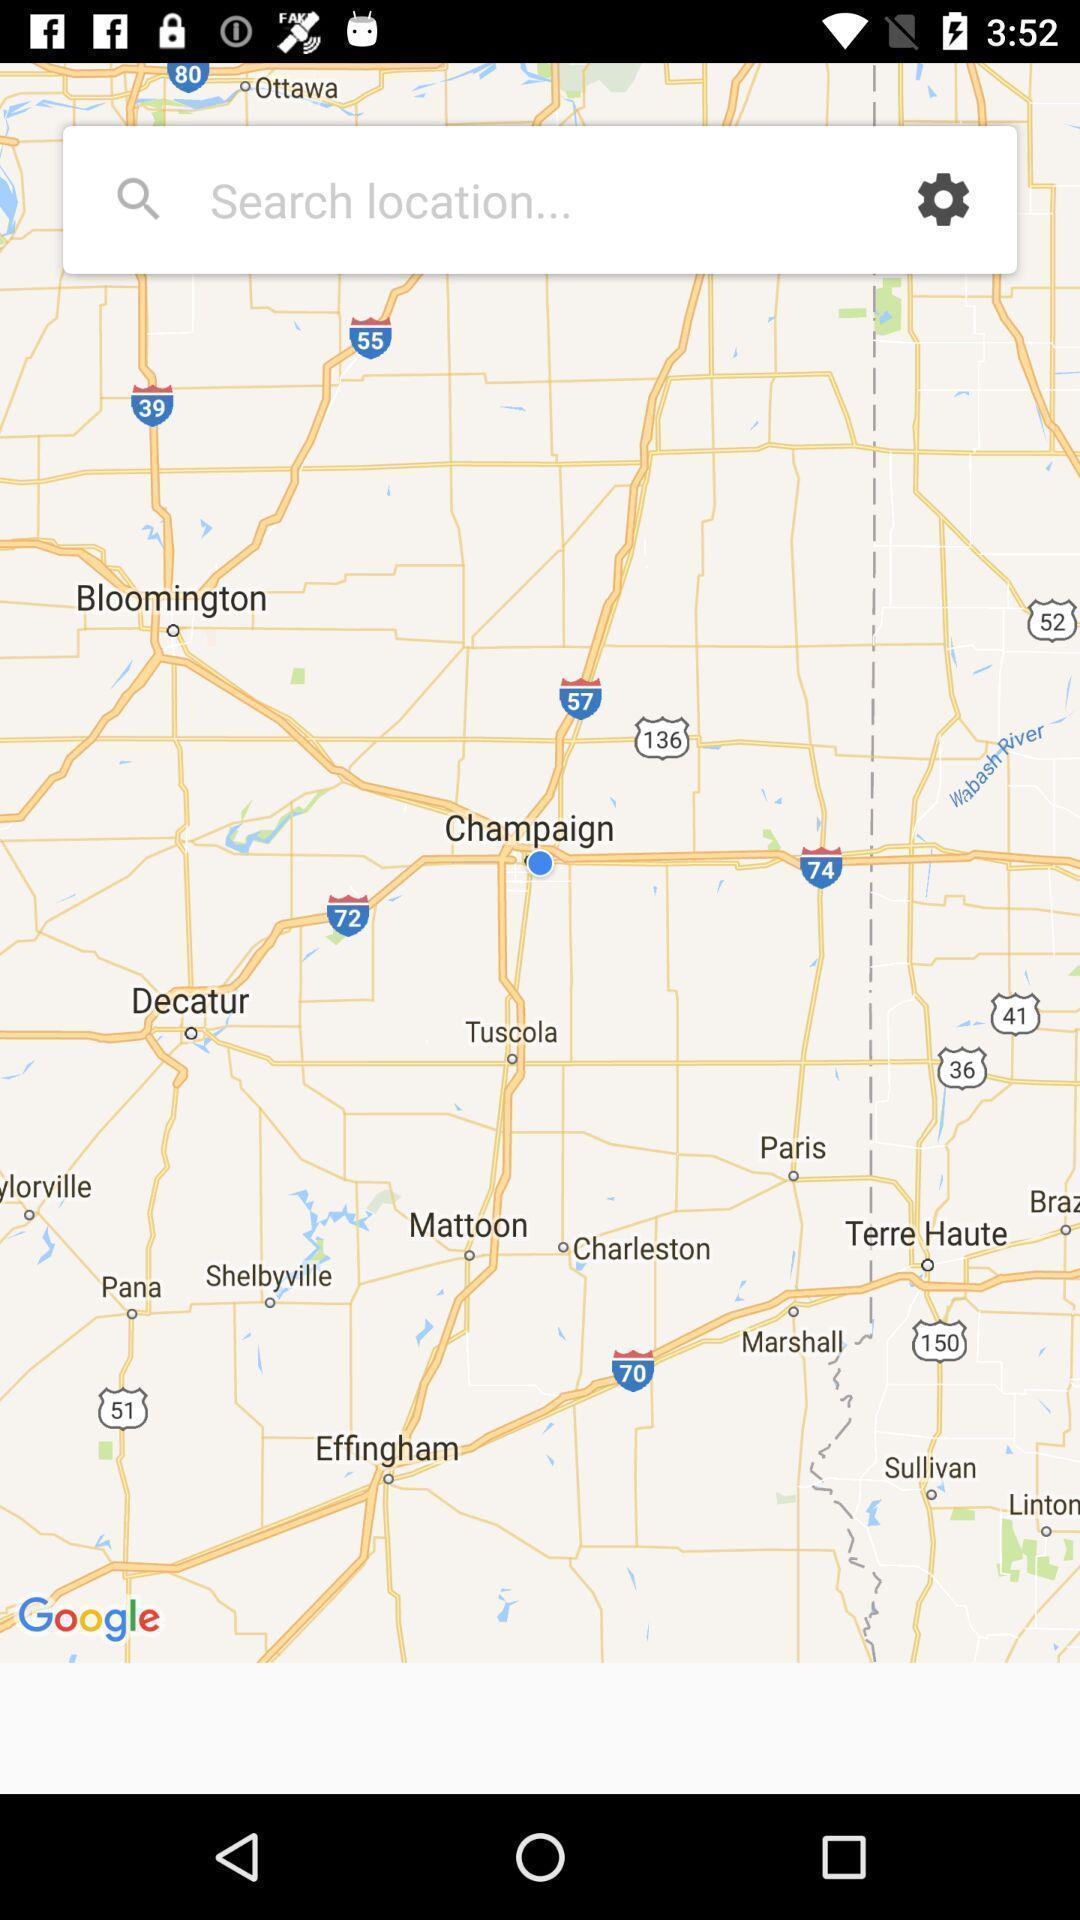Explain the elements present in this screenshot. Search location page of a tide app. 